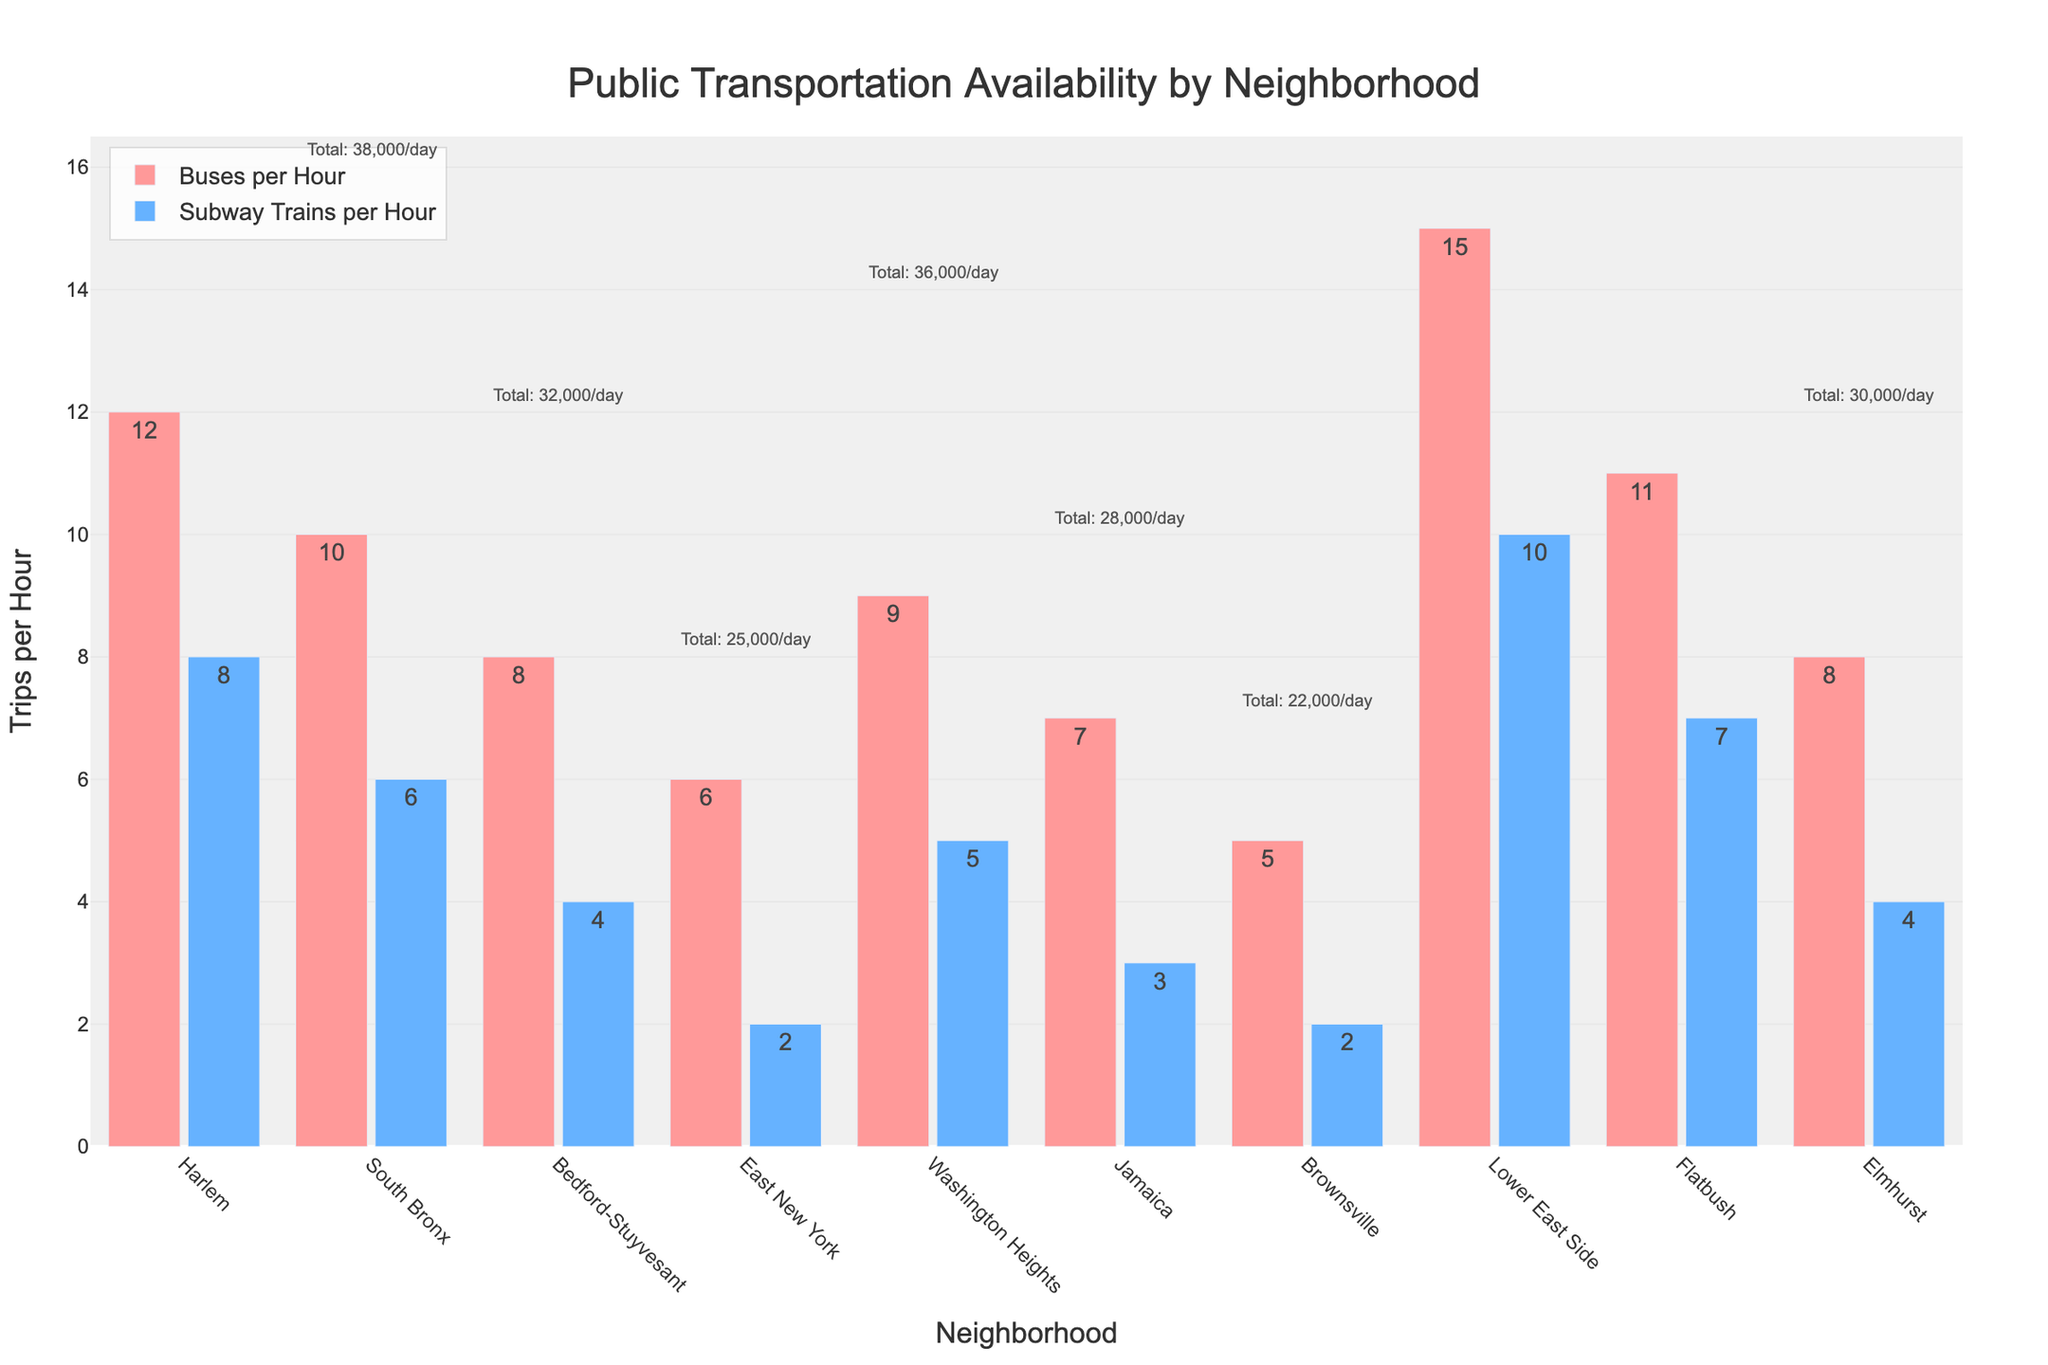Which neighborhood has the highest number of buses per hour? By looking at the heights of the red bars, the Lower East Side has the tallest red bar, indicating the highest number of buses per hour.
Answer: Lower East Side Which neighborhood has more subway trains per hour, Harlem or Elmhurst? By comparing the heights of the blue bars, Harlem has more subway trains per hour than Elmhurst.
Answer: Harlem What is the total number of transit trips per day in Flatbush? The text annotation above the bars for Flatbush reads "Total: 42,000/day," which indicates that Flatbush has 42,000 total transit trips per day.
Answer: 42,000 What is the difference in the number of buses per hour between South Bronx and Brownsville? The height of the red bar for South Bronx is 10 and for Brownsville is 5, so the difference is 10 - 5 = 5 buses per hour.
Answer: 5 Which neighborhood has the lowest total transit trips per day? By looking at the text annotations above the bars, Brownsville has the lowest total transit trips per day, which is 22,000/day.
Answer: Brownsville How many more buses per hour does Lower East Side have compared to Jamaica? Lower East Side has 15 buses per hour, and Jamaica has 7 buses per hour. The difference is 15 - 7 = 8 buses per hour.
Answer: 8 What is the combined total of buses and subway trains per hour in Washington Heights? The number of buses per hour in Washington Heights is 9, and the number of subway trains per hour is 5. The combined total is 9 + 5 = 14 trips per hour.
Answer: 14 Which neighborhood has the highest total transit trips per day, and how many more trips is it than in East New York? Lower East Side has the highest total transit trips per day with 52,000/day. East New York has 25,000/day. The difference is 52,000 - 25,000 = 27,000.
Answer: Lower East Side, 27,000 What is the average number of buses per hour across all neighborhoods? To find the average, sum the numbers of buses per hour for all neighborhoods (12+10+8+6+9+7+5+15+11+8 = 91) and divide by the number of neighborhoods (10). The average is 91 / 10 = 9.1 buses per hour.
Answer: 9.1 Which neighborhood has the least subway trains per hour and what is the number? By looking at the heights of the blue bars, both East New York and Brownsville have the smallest blue bars, indicating 2 subway trains per hour.
Answer: East New York and Brownsville, 2 